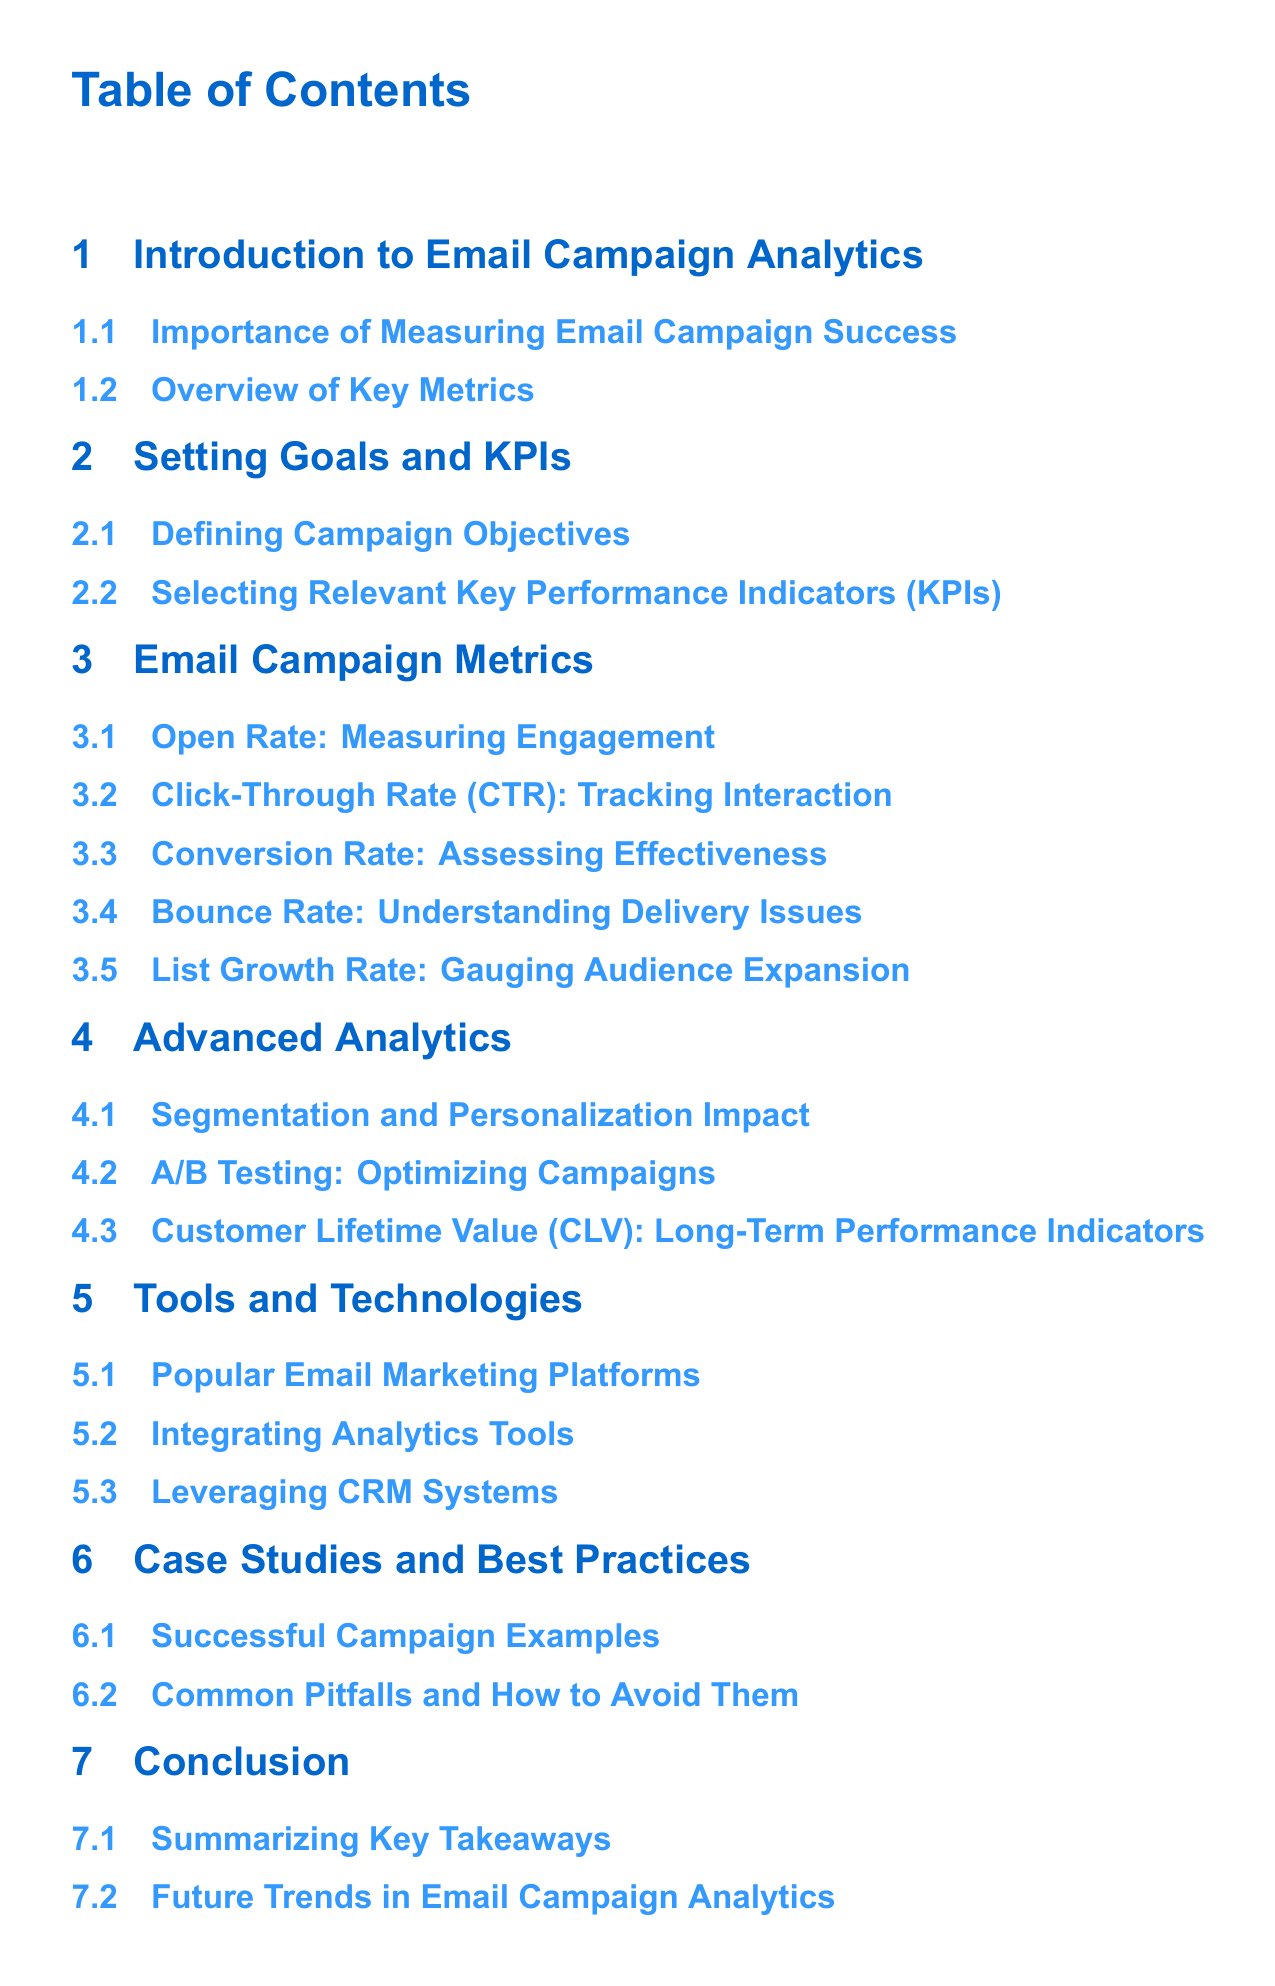What is the first section title? The first section title listed in the Table of Contents is "Introduction to Email Campaign Analytics".
Answer: Introduction to Email Campaign Analytics How many main sections are in the document? The document contains a total of six main sections outlined in the Table of Contents.
Answer: 6 What metric measures engagement specifically? The metric that measures engagement is mentioned as "Open Rate" in the document.
Answer: Open Rate Which advanced analytics technique is mentioned for optimizing campaigns? The document refers to "A/B Testing" as an advanced analytics technique for optimizing campaigns.
Answer: A/B Testing What is the focus of the section after "Setting Goals and KPIs"? The section following "Setting Goals and KPIs" focuses on "Email Campaign Metrics".
Answer: Email Campaign Metrics What is a common pitfall discussed in the case studies section? The document refers to "Common Pitfalls and How to Avoid Them" in the case studies section, implying there are multiple pitfalls discussed.
Answer: Common Pitfalls and How to Avoid Them What is highlighted as a long-term performance indicator? The document highlights "Customer Lifetime Value (CLV)" as a long-term performance indicator.
Answer: Customer Lifetime Value (CLV) What tool is suggested for integrating analytics? The section mentions "Integrating Analytics Tools" as a part of the discussion on tools and technologies.
Answer: Integrating Analytics Tools How is the importance of email campaign success characterized? The document discusses the "Importance of Measuring Email Campaign Success" in the introduction.
Answer: Importance of Measuring Email Campaign Success 